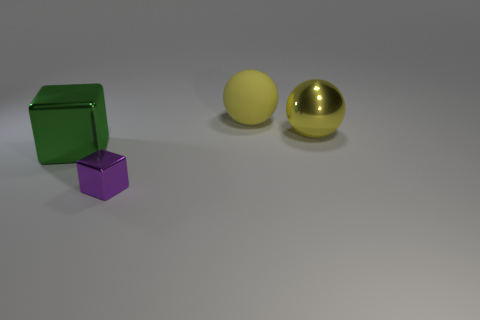Add 2 small blue things. How many objects exist? 6 Subtract all purple blocks. How many blocks are left? 1 Subtract 1 spheres. How many spheres are left? 1 Subtract all yellow things. Subtract all tiny shiny blocks. How many objects are left? 1 Add 2 large green metal cubes. How many large green metal cubes are left? 3 Add 2 tiny purple matte objects. How many tiny purple matte objects exist? 2 Subtract 0 green spheres. How many objects are left? 4 Subtract all purple blocks. Subtract all red cylinders. How many blocks are left? 1 